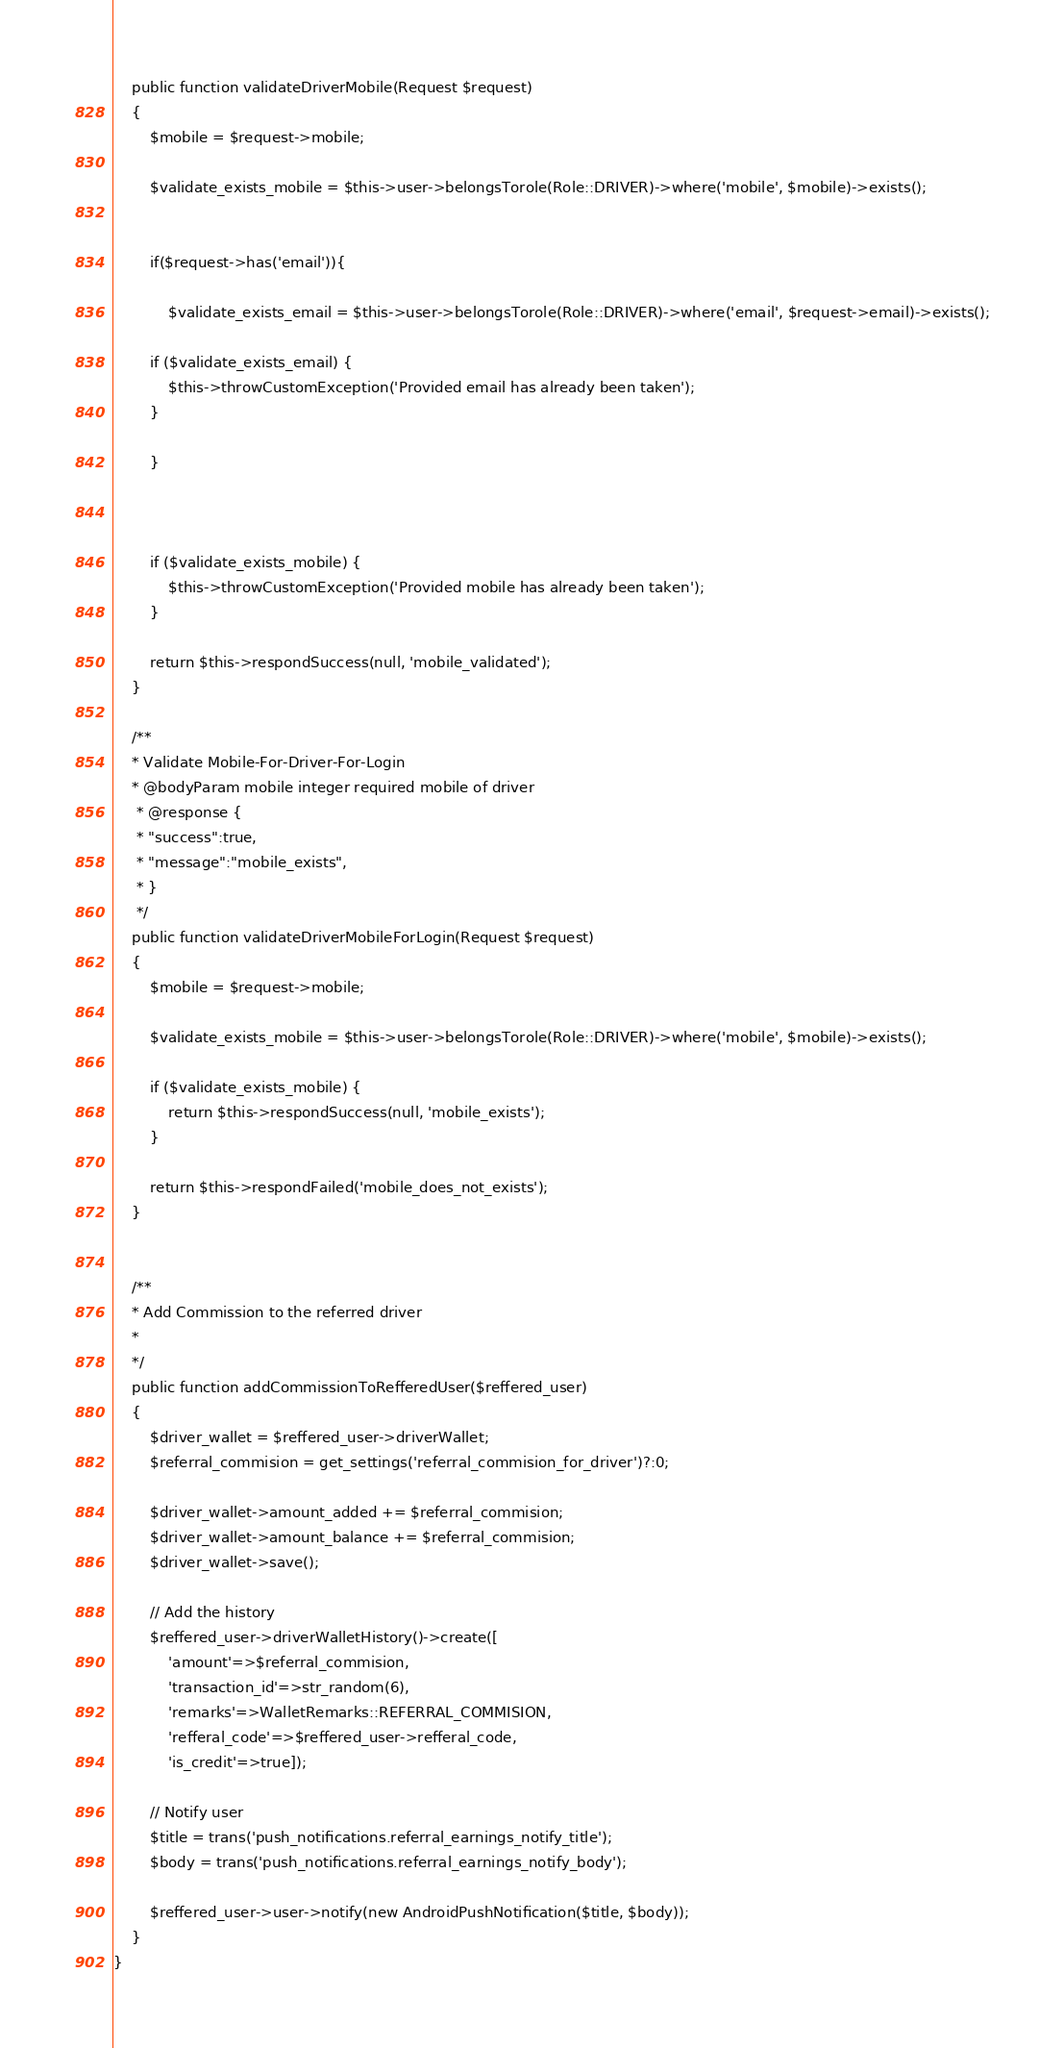Convert code to text. <code><loc_0><loc_0><loc_500><loc_500><_PHP_>    public function validateDriverMobile(Request $request)
    {
        $mobile = $request->mobile;

        $validate_exists_mobile = $this->user->belongsTorole(Role::DRIVER)->where('mobile', $mobile)->exists();


        if($request->has('email')){

            $validate_exists_email = $this->user->belongsTorole(Role::DRIVER)->where('email', $request->email)->exists();

        if ($validate_exists_email) {
            $this->throwCustomException('Provided email has already been taken');
        }
        
        }
        


        if ($validate_exists_mobile) {
            $this->throwCustomException('Provided mobile has already been taken');
        }

        return $this->respondSuccess(null, 'mobile_validated');
    }
   
    /**
    * Validate Mobile-For-Driver-For-Login
    * @bodyParam mobile integer required mobile of driver
     * @response {
     * "success":true,
     * "message":"mobile_exists",
     * }
     */
    public function validateDriverMobileForLogin(Request $request)
    {
        $mobile = $request->mobile;

        $validate_exists_mobile = $this->user->belongsTorole(Role::DRIVER)->where('mobile', $mobile)->exists();

        if ($validate_exists_mobile) {
            return $this->respondSuccess(null, 'mobile_exists');
        }

        return $this->respondFailed('mobile_does_not_exists');
    }


    /**
    * Add Commission to the referred driver
    *
    */
    public function addCommissionToRefferedUser($reffered_user)
    {
        $driver_wallet = $reffered_user->driverWallet;
        $referral_commision = get_settings('referral_commision_for_driver')?:0;

        $driver_wallet->amount_added += $referral_commision;
        $driver_wallet->amount_balance += $referral_commision;
        $driver_wallet->save();

        // Add the history
        $reffered_user->driverWalletHistory()->create([
            'amount'=>$referral_commision,
            'transaction_id'=>str_random(6),
            'remarks'=>WalletRemarks::REFERRAL_COMMISION,
            'refferal_code'=>$reffered_user->refferal_code,
            'is_credit'=>true]);

        // Notify user
        $title = trans('push_notifications.referral_earnings_notify_title');
        $body = trans('push_notifications.referral_earnings_notify_body');

        $reffered_user->user->notify(new AndroidPushNotification($title, $body));
    }
}
</code> 